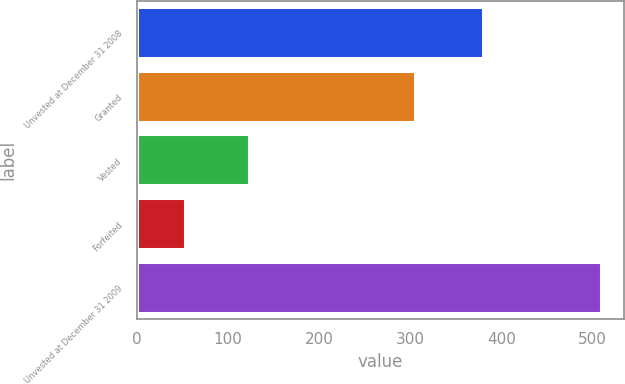Convert chart to OTSL. <chart><loc_0><loc_0><loc_500><loc_500><bar_chart><fcel>Unvested at December 31 2008<fcel>Granted<fcel>Vested<fcel>Forfeited<fcel>Unvested at December 31 2009<nl><fcel>380<fcel>305<fcel>123<fcel>53<fcel>509<nl></chart> 